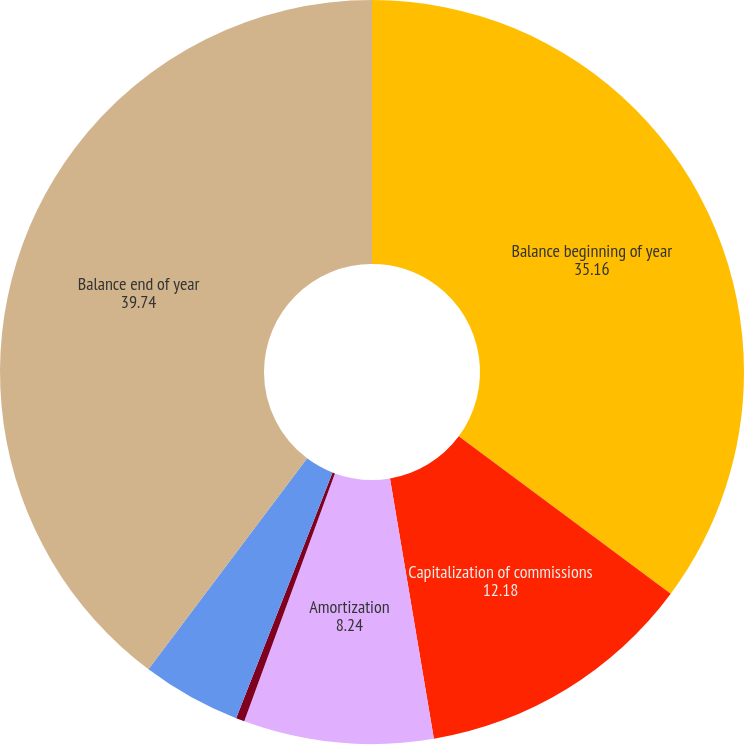Convert chart. <chart><loc_0><loc_0><loc_500><loc_500><pie_chart><fcel>Balance beginning of year<fcel>Capitalization of commissions<fcel>Amortization<fcel>Change in unrealized<fcel>Foreign currency translation<fcel>Balance end of year<nl><fcel>35.16%<fcel>12.18%<fcel>8.24%<fcel>0.37%<fcel>4.31%<fcel>39.74%<nl></chart> 